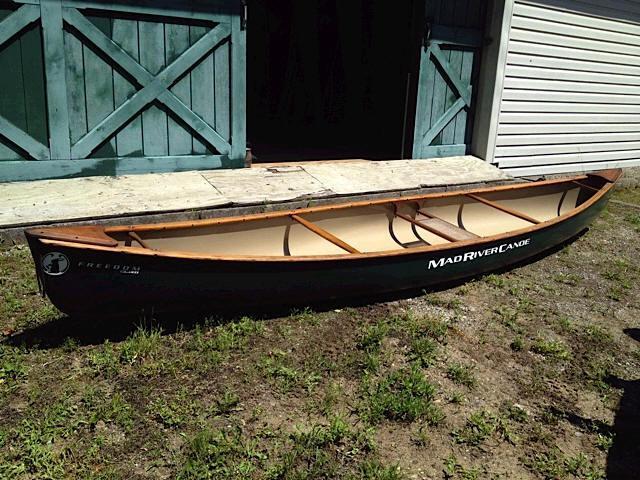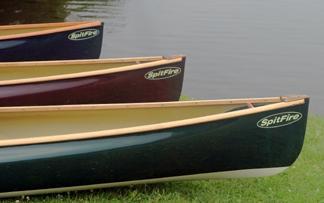The first image is the image on the left, the second image is the image on the right. For the images shown, is this caption "One image shows multiple canoes with rowers in them heading leftward, and the other image features a single riderless canoe containing fishing poles floating on the water." true? Answer yes or no. No. The first image is the image on the left, the second image is the image on the right. Analyze the images presented: Is the assertion "There is exactly one canoe without anyone in it." valid? Answer yes or no. No. 